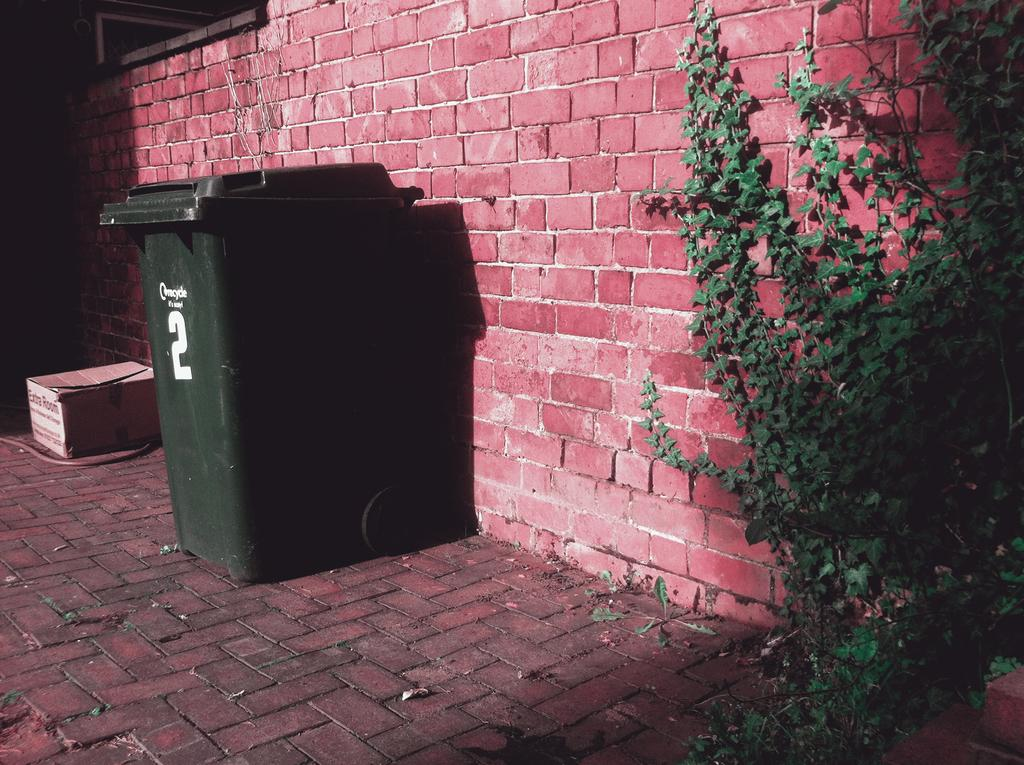<image>
Offer a succinct explanation of the picture presented. A extra room box is sitting on the ground next to a green trash can. 